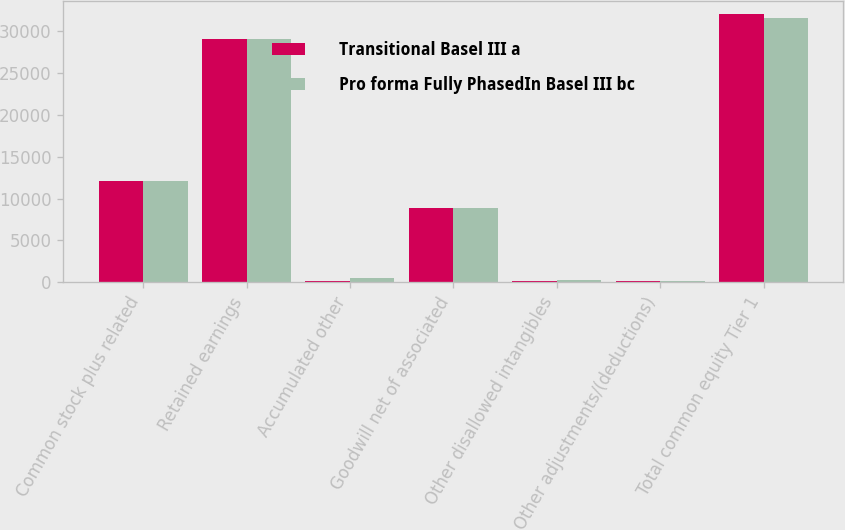Convert chart. <chart><loc_0><loc_0><loc_500><loc_500><stacked_bar_chart><ecel><fcel>Common stock plus related<fcel>Retained earnings<fcel>Accumulated other<fcel>Goodwill net of associated<fcel>Other disallowed intangibles<fcel>Other adjustments/(deductions)<fcel>Total common equity Tier 1<nl><fcel>Transitional Basel III a<fcel>12085<fcel>29043<fcel>222<fcel>8839<fcel>133<fcel>112<fcel>31963<nl><fcel>Pro forma Fully PhasedIn Basel III bc<fcel>12085<fcel>29043<fcel>554<fcel>8839<fcel>333<fcel>182<fcel>31573<nl></chart> 